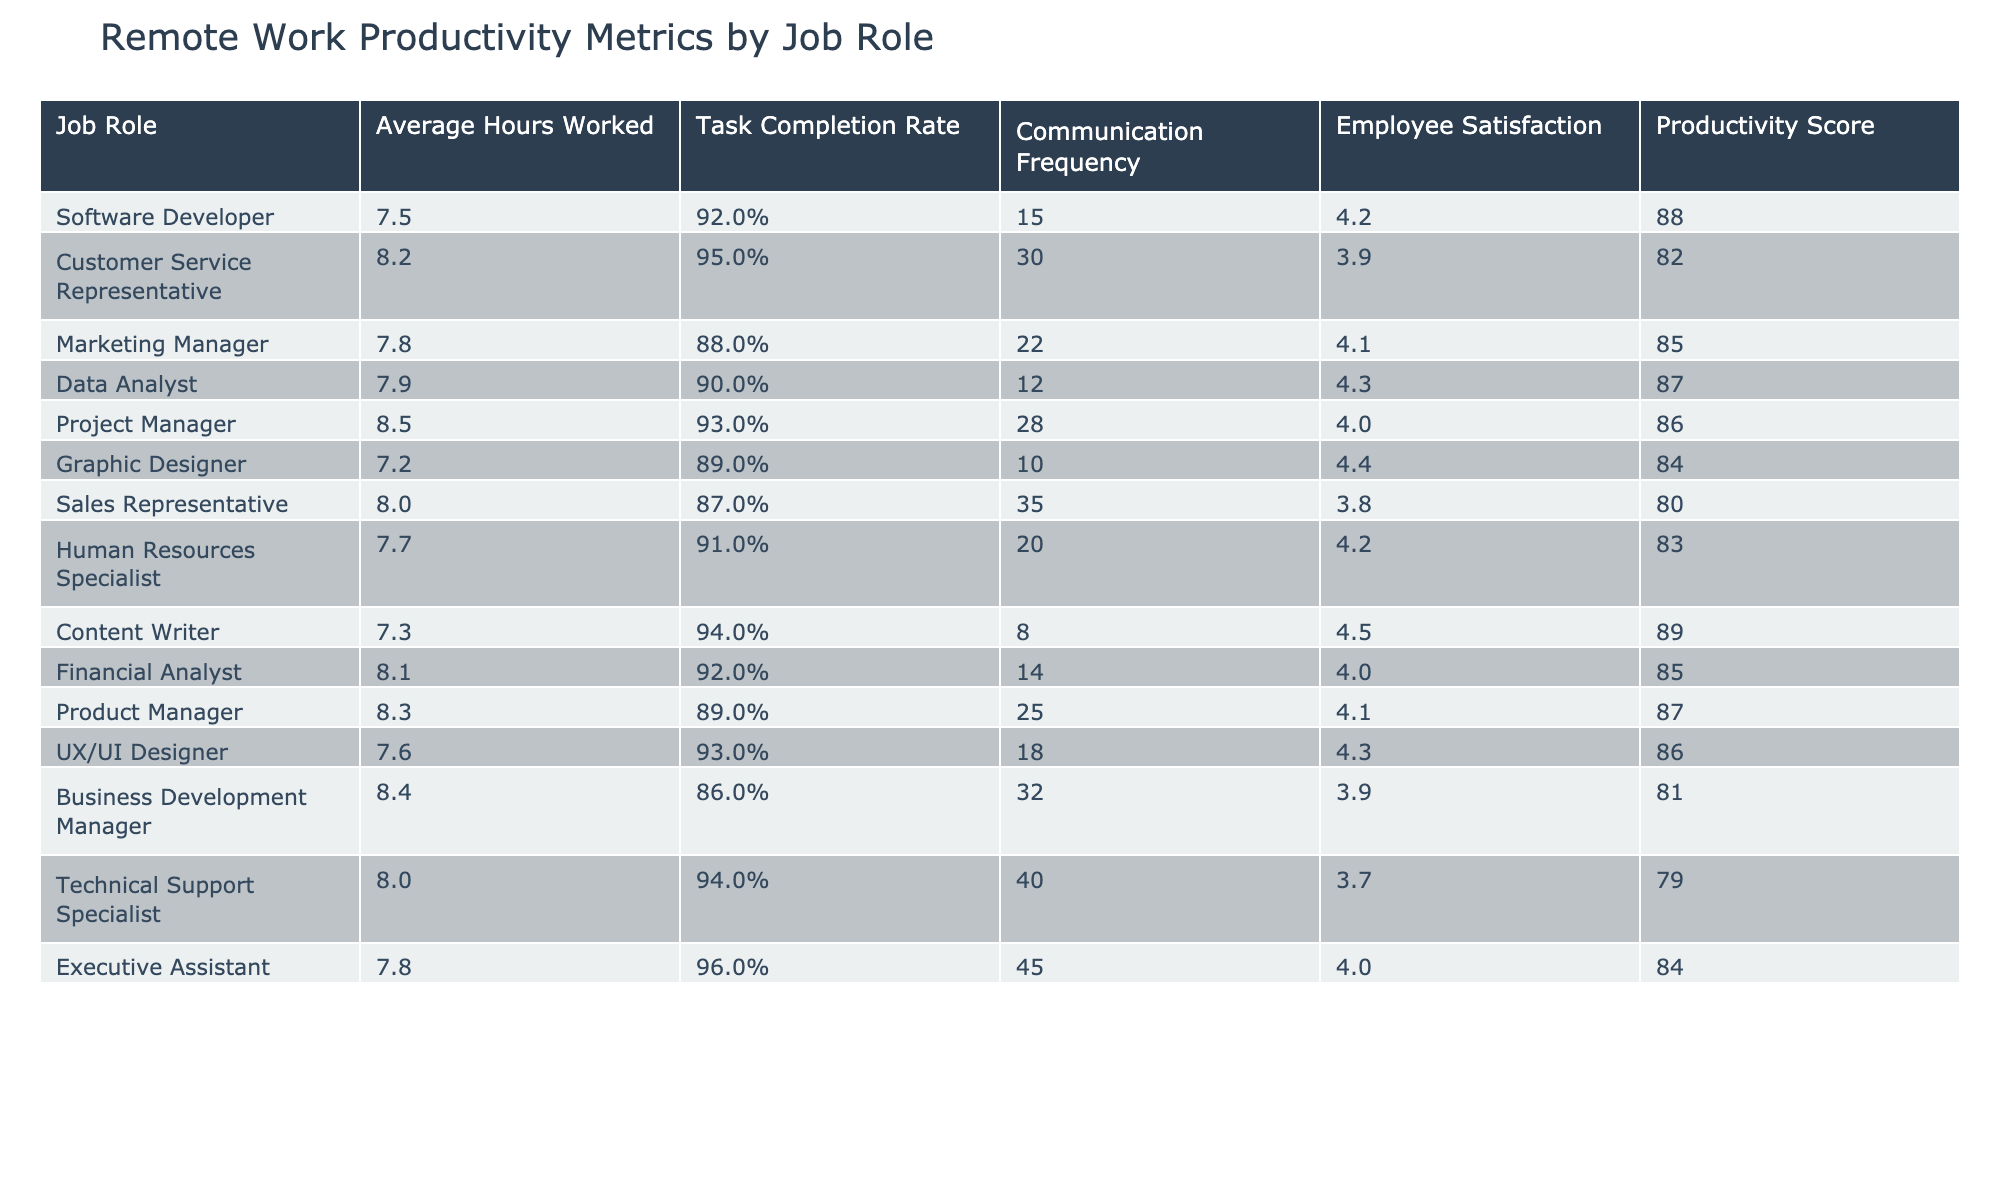What is the average number of hours worked by a Software Developer? The table lists that the average hours worked by a Software Developer is 7.5 hours.
Answer: 7.5 Which job role has the highest task completion rate? The task completion rates indicate that the Executive Assistant has the highest task completion rate at 96%.
Answer: Executive Assistant What is the average employee satisfaction score for Customer Service Representatives and Technical Support Specialists combined? The average employee satisfaction score for Customer Service Representatives is 3.9 and for Technical Support Specialists is 3.7. Adding these together gives 3.9 + 3.7 = 7.6. Then dividing by 2 gives 7.6/2 = 3.8.
Answer: 3.8 Does the Project Manager have a higher communication frequency than the Graphic Designer? The Project Manager's communication frequency is 28, while the Graphic Designer's is 10. Since 28 is greater than 10, the statement is true.
Answer: Yes What is the productivity score difference between the Marketing Manager and the Sales Representative? The productivity score for the Marketing Manager is 85, and for the Sales Representative, it is 80. The difference is calculated as 85 - 80 = 5.
Answer: 5 Which job roles have an average of more than 8 hours worked, and what is their communication frequency? The job roles that average more than 8 hours worked are Customer Service Representative (30), Project Manager (28), Financial Analyst (14), Business Development Manager (32), and Technical Support Specialist (40).
Answer: Customer Service Representative: 30, Project Manager: 28, Financial Analyst: 14, Business Development Manager: 32, Technical Support Specialist: 40 What is the average productivity score for all roles with an average of less than 7.5 hours worked? The roles with less than 7.5 hours worked are Graphic Designer (84), Content Writer (89), and Software Developer (88). Summing the productivity scores gives 84 + 89 + 88 = 261, and dividing by 3 gives an average of 261/3 = 87.
Answer: 87 Is the satisfaction score for Data Analysts higher than that of Sales Representatives? The satisfaction score for Data Analysts is 4.3, while for Sales Representatives, it is 3.8. Since 4.3 is greater than 3.8, the statement is true.
Answer: Yes Which job role works the fewest average hours, and what is its productivity score? The job role with the fewest average hours worked is Graphic Designer at 7.2 hours, and its productivity score is 84.
Answer: Graphic Designer, 84 If the Employee Satisfaction and Productivity Score have a correlation, which role has the highest combined score? The highest combined score of Employee Satisfaction and Productivity Score is for Content Writer which has 4.5 + 89 = 93.5.
Answer: Content Writer, 93.5 How many job roles have a task completion rate of 90% or higher and what is their average satisfaction score? The roles with 90% or higher task completion rates are Software Developer, Customer Service Representative, Project Manager, Data Analyst, UX/UI Designer, Executive Assistant. Their satisfaction scores are 4.2, 3.9, 4.0, 4.3, 4.3, and 4.0. Summing gives 24.7, averaging 24.7/6 = 4.12.
Answer: 6 roles, 4.12 